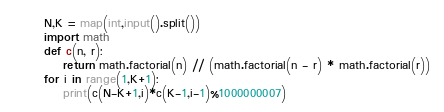Convert code to text. <code><loc_0><loc_0><loc_500><loc_500><_Python_>N,K = map(int,input().split())
import math
def c(n, r):
    return math.factorial(n) // (math.factorial(n - r) * math.factorial(r))
for i in range(1,K+1):
    print(c(N-K+1,i)*c(K-1,i-1)%1000000007)</code> 